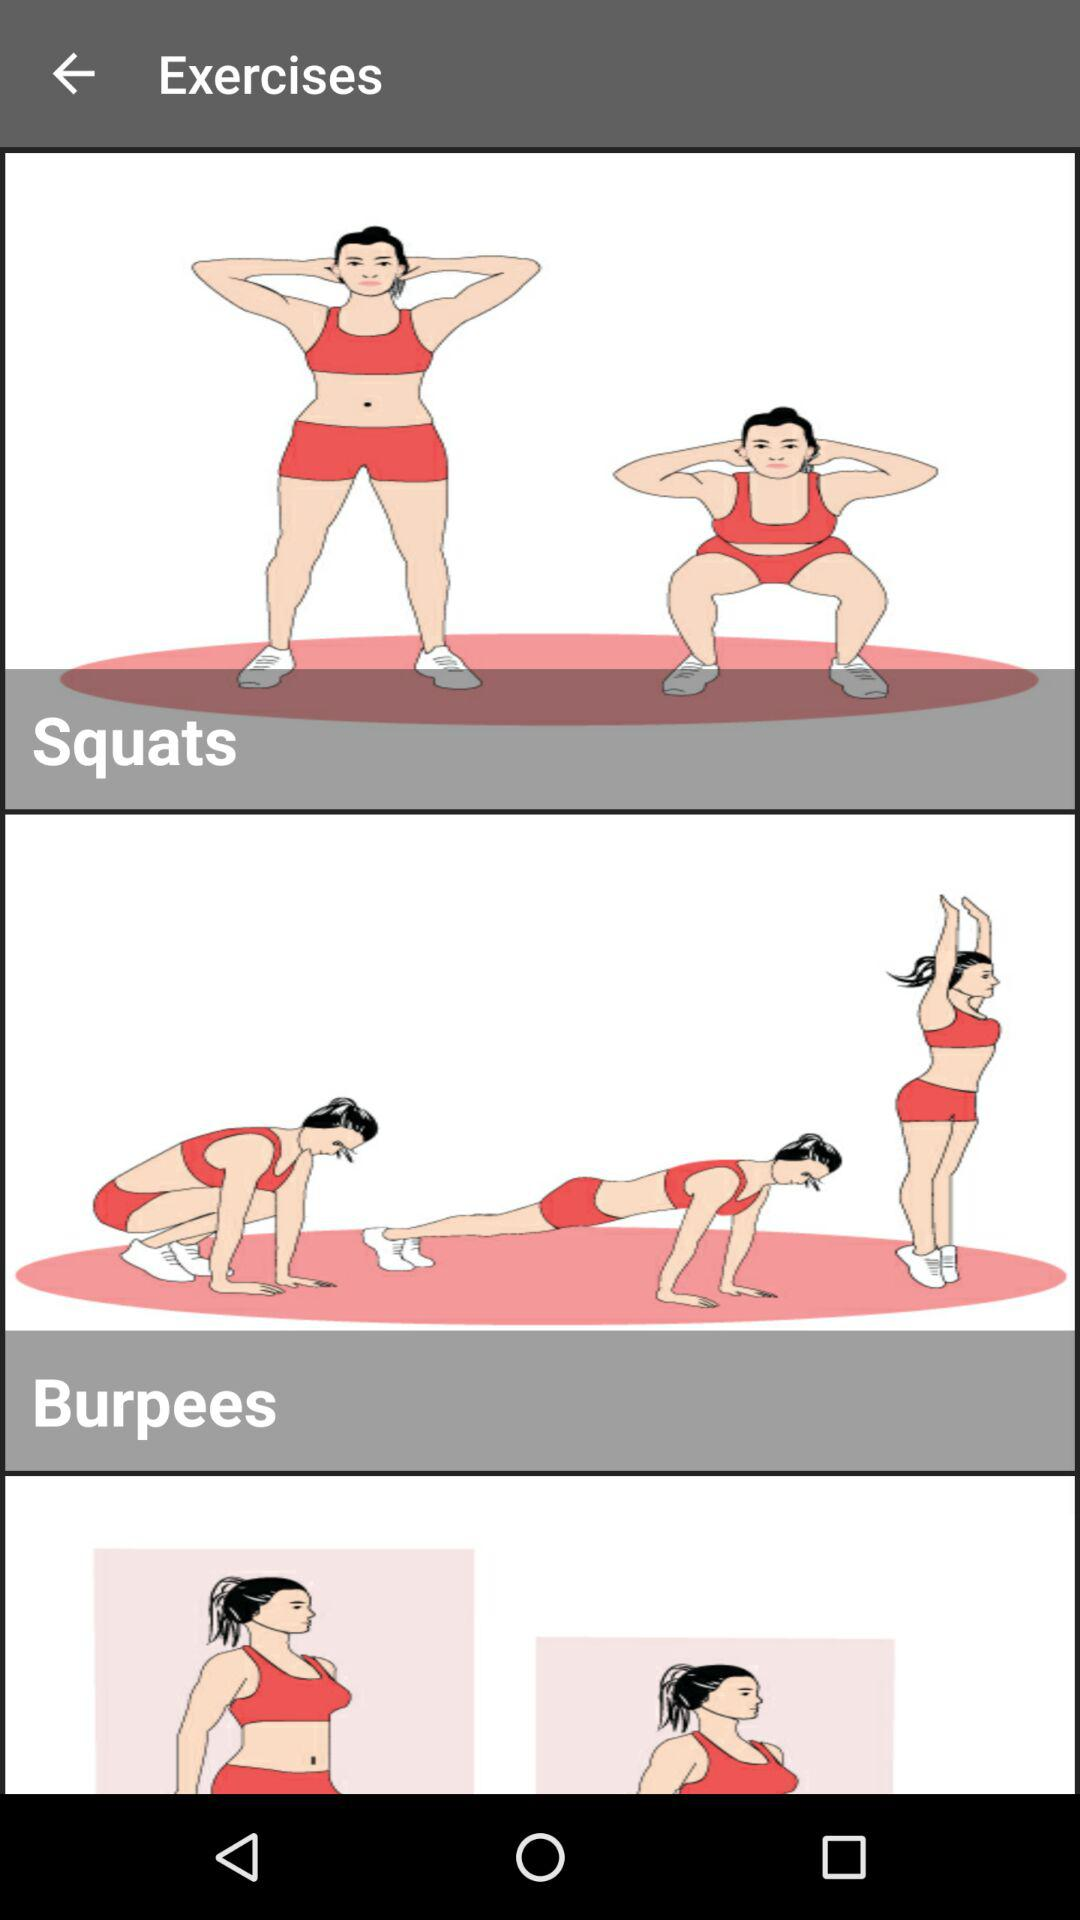What are the different types of exercise there are? The types of exercise are squats and burpees. 